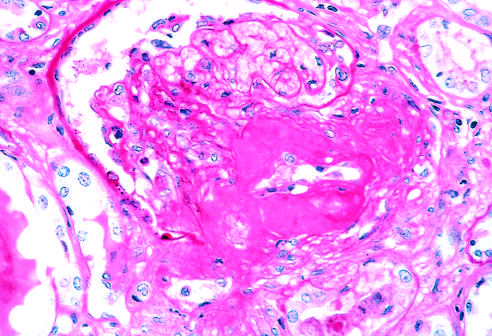s the amorphous nature of the thickened vascular wall evident?
Answer the question using a single word or phrase. Yes 